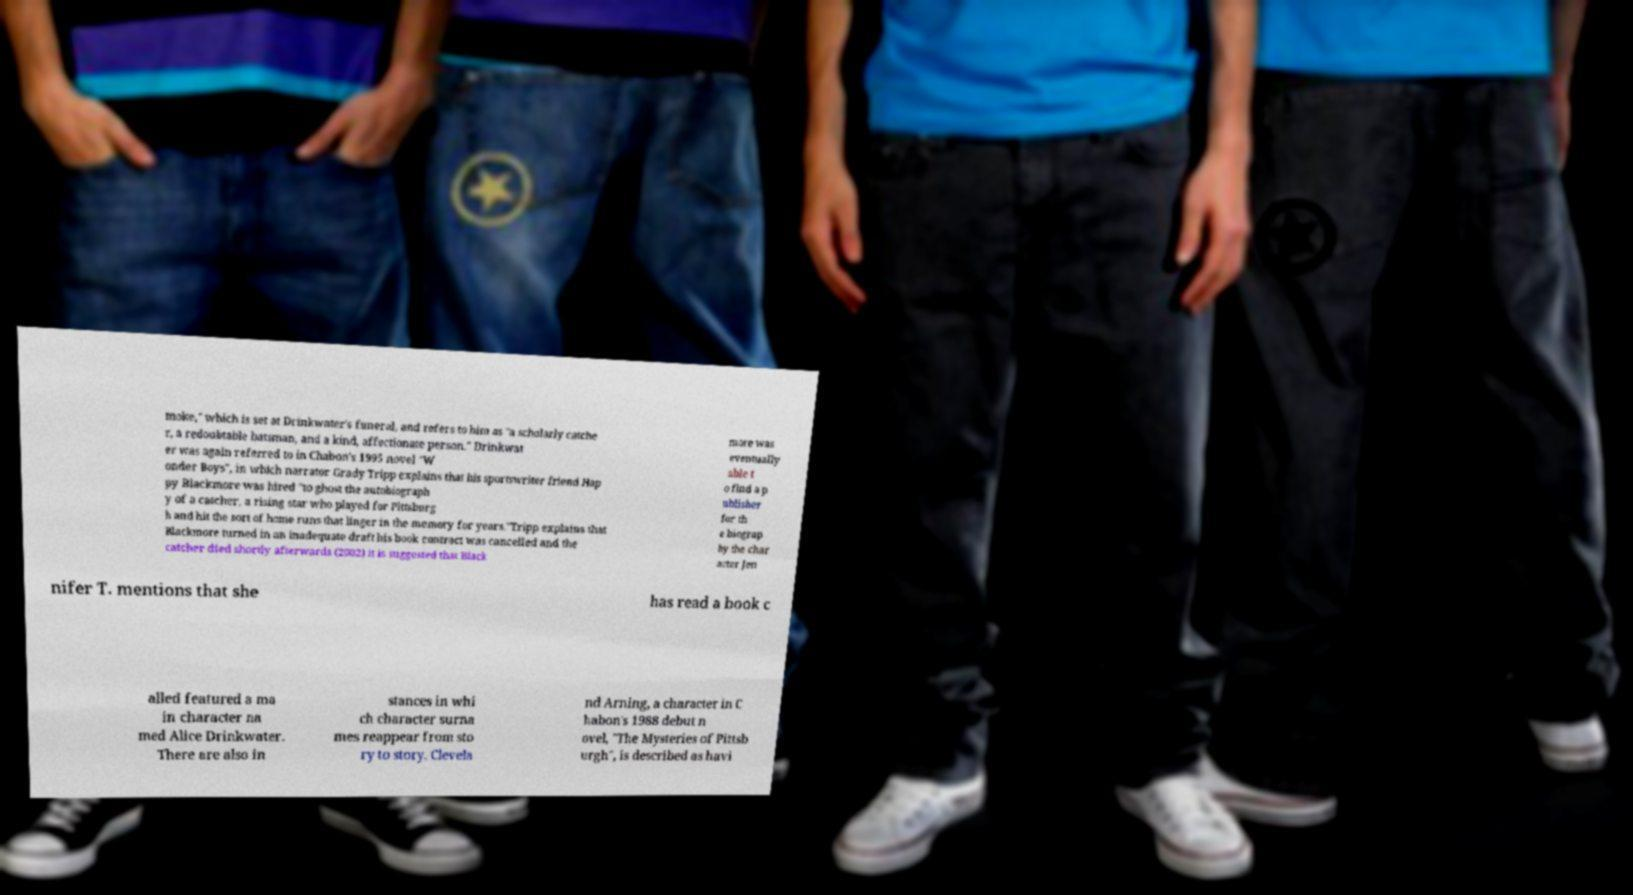Can you read and provide the text displayed in the image?This photo seems to have some interesting text. Can you extract and type it out for me? moke," which is set at Drinkwater's funeral, and refers to him as "a scholarly catche r, a redoubtable batsman, and a kind, affectionate person." Drinkwat er was again referred to in Chabon's 1995 novel "W onder Boys", in which narrator Grady Tripp explains that his sportswriter friend Hap py Blackmore was hired "to ghost the autobiograph y of a catcher, a rising star who played for Pittsburg h and hit the sort of home runs that linger in the memory for years."Tripp explains that Blackmore turned in an inadequate draft his book contract was cancelled and the catcher died shortly afterwards (2002) it is suggested that Black more was eventually able t o find a p ublisher for th e biograp hy the char acter Jen nifer T. mentions that she has read a book c alled featured a ma in character na med Alice Drinkwater. There are also in stances in whi ch character surna mes reappear from sto ry to story. Clevela nd Arning, a character in C habon's 1988 debut n ovel, "The Mysteries of Pittsb urgh", is described as havi 